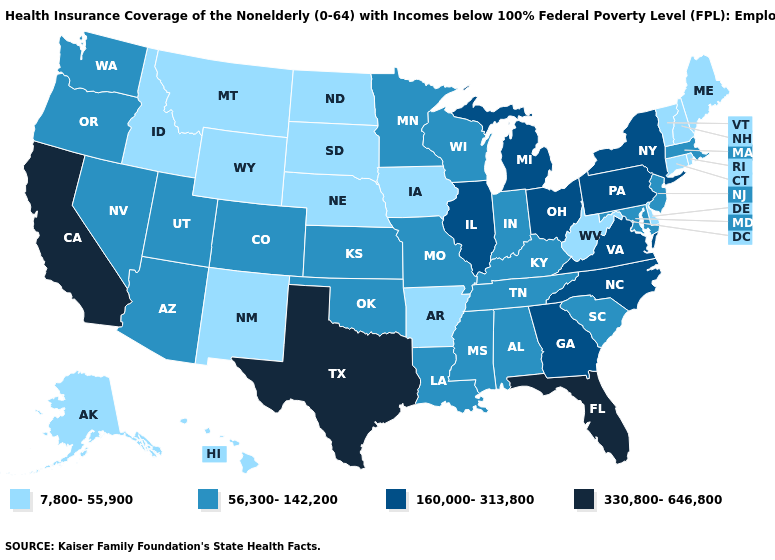What is the value of Delaware?
Write a very short answer. 7,800-55,900. Name the states that have a value in the range 56,300-142,200?
Be succinct. Alabama, Arizona, Colorado, Indiana, Kansas, Kentucky, Louisiana, Maryland, Massachusetts, Minnesota, Mississippi, Missouri, Nevada, New Jersey, Oklahoma, Oregon, South Carolina, Tennessee, Utah, Washington, Wisconsin. Name the states that have a value in the range 7,800-55,900?
Short answer required. Alaska, Arkansas, Connecticut, Delaware, Hawaii, Idaho, Iowa, Maine, Montana, Nebraska, New Hampshire, New Mexico, North Dakota, Rhode Island, South Dakota, Vermont, West Virginia, Wyoming. What is the lowest value in states that border Minnesota?
Be succinct. 7,800-55,900. Does the first symbol in the legend represent the smallest category?
Keep it brief. Yes. Does Georgia have a higher value than Kansas?
Answer briefly. Yes. What is the value of Florida?
Give a very brief answer. 330,800-646,800. What is the value of Rhode Island?
Be succinct. 7,800-55,900. Name the states that have a value in the range 330,800-646,800?
Keep it brief. California, Florida, Texas. Does Hawaii have the lowest value in the West?
Concise answer only. Yes. What is the value of Utah?
Concise answer only. 56,300-142,200. Does North Dakota have a lower value than Hawaii?
Answer briefly. No. How many symbols are there in the legend?
Be succinct. 4. Is the legend a continuous bar?
Answer briefly. No. Name the states that have a value in the range 7,800-55,900?
Concise answer only. Alaska, Arkansas, Connecticut, Delaware, Hawaii, Idaho, Iowa, Maine, Montana, Nebraska, New Hampshire, New Mexico, North Dakota, Rhode Island, South Dakota, Vermont, West Virginia, Wyoming. 